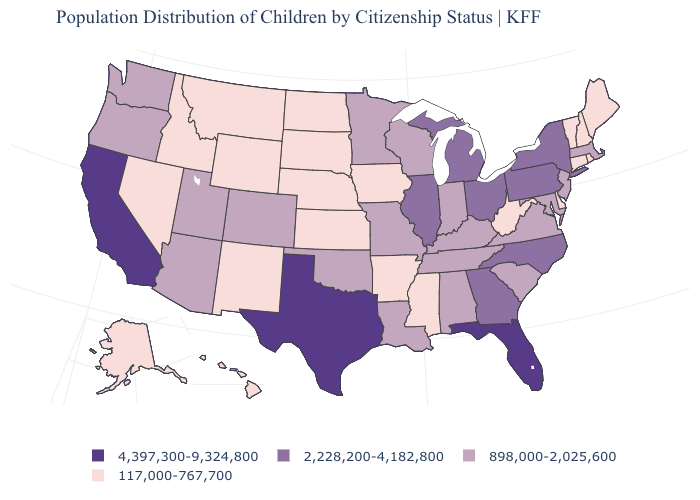What is the lowest value in states that border New Jersey?
Be succinct. 117,000-767,700. Does the first symbol in the legend represent the smallest category?
Short answer required. No. Among the states that border Pennsylvania , which have the lowest value?
Keep it brief. Delaware, West Virginia. What is the value of Vermont?
Be succinct. 117,000-767,700. Name the states that have a value in the range 117,000-767,700?
Concise answer only. Alaska, Arkansas, Connecticut, Delaware, Hawaii, Idaho, Iowa, Kansas, Maine, Mississippi, Montana, Nebraska, Nevada, New Hampshire, New Mexico, North Dakota, Rhode Island, South Dakota, Vermont, West Virginia, Wyoming. What is the value of North Dakota?
Write a very short answer. 117,000-767,700. Name the states that have a value in the range 2,228,200-4,182,800?
Write a very short answer. Georgia, Illinois, Michigan, New York, North Carolina, Ohio, Pennsylvania. Does the first symbol in the legend represent the smallest category?
Short answer required. No. What is the value of Colorado?
Keep it brief. 898,000-2,025,600. Name the states that have a value in the range 4,397,300-9,324,800?
Write a very short answer. California, Florida, Texas. Does New York have a lower value than South Dakota?
Give a very brief answer. No. Name the states that have a value in the range 4,397,300-9,324,800?
Concise answer only. California, Florida, Texas. Among the states that border Texas , does New Mexico have the lowest value?
Quick response, please. Yes. Name the states that have a value in the range 4,397,300-9,324,800?
Quick response, please. California, Florida, Texas. How many symbols are there in the legend?
Answer briefly. 4. 